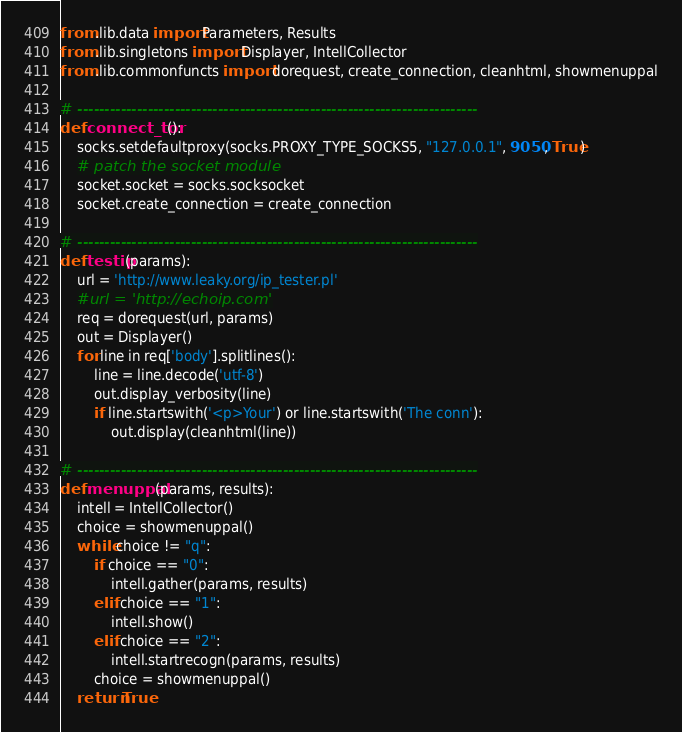Convert code to text. <code><loc_0><loc_0><loc_500><loc_500><_Python_>from .lib.data import Parameters, Results
from .lib.singletons import Displayer, IntellCollector
from .lib.commonfuncts import dorequest, create_connection, cleanhtml, showmenuppal

# --------------------------------------------------------------------------
def connect_tor():
    socks.setdefaultproxy(socks.PROXY_TYPE_SOCKS5, "127.0.0.1", 9050, True)
    # patch the socket module
    socket.socket = socks.socksocket
    socket.create_connection = create_connection

# --------------------------------------------------------------------------
def testip(params):
    url = 'http://www.leaky.org/ip_tester.pl'
    #url = 'http://echoip.com'
    req = dorequest(url, params)
    out = Displayer()
    for line in req['body'].splitlines():
        line = line.decode('utf-8')
        out.display_verbosity(line)
        if line.startswith('<p>Your') or line.startswith('The conn'):
            out.display(cleanhtml(line))

# --------------------------------------------------------------------------
def menuppal(params, results):
    intell = IntellCollector()
    choice = showmenuppal()
    while choice != "q":
        if choice == "0":
            intell.gather(params, results)
        elif choice == "1":
            intell.show()
        elif choice == "2":
            intell.startrecogn(params, results)
        choice = showmenuppal()
    return True
</code> 